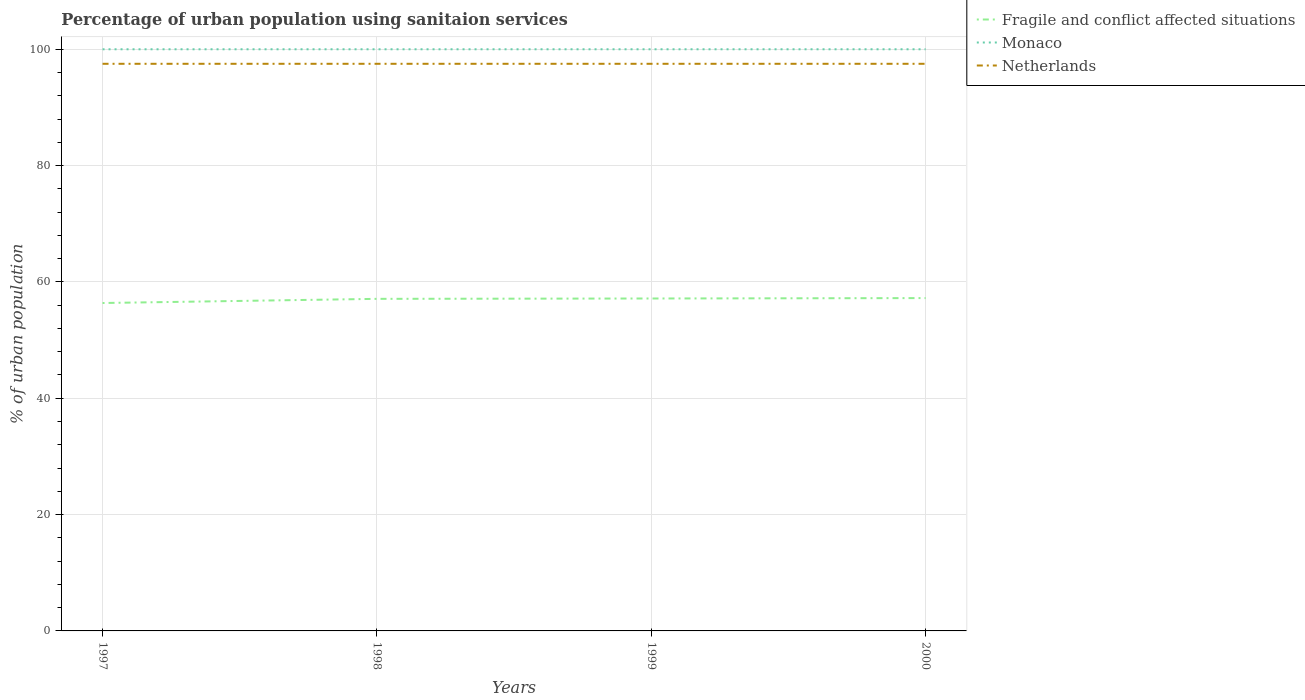Is the number of lines equal to the number of legend labels?
Make the answer very short. Yes. Across all years, what is the maximum percentage of urban population using sanitaion services in Netherlands?
Your response must be concise. 97.5. In which year was the percentage of urban population using sanitaion services in Netherlands maximum?
Provide a succinct answer. 1997. What is the total percentage of urban population using sanitaion services in Monaco in the graph?
Keep it short and to the point. 0. What is the difference between the highest and the second highest percentage of urban population using sanitaion services in Fragile and conflict affected situations?
Offer a terse response. 0.85. Is the percentage of urban population using sanitaion services in Fragile and conflict affected situations strictly greater than the percentage of urban population using sanitaion services in Monaco over the years?
Provide a short and direct response. Yes. How many lines are there?
Your answer should be compact. 3. What is the difference between two consecutive major ticks on the Y-axis?
Keep it short and to the point. 20. Are the values on the major ticks of Y-axis written in scientific E-notation?
Provide a succinct answer. No. Does the graph contain any zero values?
Keep it short and to the point. No. Does the graph contain grids?
Provide a succinct answer. Yes. Where does the legend appear in the graph?
Offer a very short reply. Top right. How are the legend labels stacked?
Provide a succinct answer. Vertical. What is the title of the graph?
Offer a very short reply. Percentage of urban population using sanitaion services. What is the label or title of the X-axis?
Ensure brevity in your answer.  Years. What is the label or title of the Y-axis?
Ensure brevity in your answer.  % of urban population. What is the % of urban population of Fragile and conflict affected situations in 1997?
Make the answer very short. 56.37. What is the % of urban population in Monaco in 1997?
Your response must be concise. 100. What is the % of urban population in Netherlands in 1997?
Keep it short and to the point. 97.5. What is the % of urban population of Fragile and conflict affected situations in 1998?
Provide a succinct answer. 57.09. What is the % of urban population of Monaco in 1998?
Provide a short and direct response. 100. What is the % of urban population in Netherlands in 1998?
Your response must be concise. 97.5. What is the % of urban population in Fragile and conflict affected situations in 1999?
Provide a succinct answer. 57.15. What is the % of urban population of Monaco in 1999?
Your answer should be compact. 100. What is the % of urban population of Netherlands in 1999?
Offer a terse response. 97.5. What is the % of urban population of Fragile and conflict affected situations in 2000?
Provide a succinct answer. 57.22. What is the % of urban population in Netherlands in 2000?
Give a very brief answer. 97.5. Across all years, what is the maximum % of urban population in Fragile and conflict affected situations?
Give a very brief answer. 57.22. Across all years, what is the maximum % of urban population in Monaco?
Your response must be concise. 100. Across all years, what is the maximum % of urban population of Netherlands?
Offer a very short reply. 97.5. Across all years, what is the minimum % of urban population in Fragile and conflict affected situations?
Offer a terse response. 56.37. Across all years, what is the minimum % of urban population in Netherlands?
Your response must be concise. 97.5. What is the total % of urban population of Fragile and conflict affected situations in the graph?
Provide a short and direct response. 227.84. What is the total % of urban population in Netherlands in the graph?
Ensure brevity in your answer.  390. What is the difference between the % of urban population in Fragile and conflict affected situations in 1997 and that in 1998?
Offer a terse response. -0.72. What is the difference between the % of urban population in Netherlands in 1997 and that in 1998?
Keep it short and to the point. 0. What is the difference between the % of urban population of Fragile and conflict affected situations in 1997 and that in 1999?
Give a very brief answer. -0.78. What is the difference between the % of urban population of Fragile and conflict affected situations in 1997 and that in 2000?
Offer a very short reply. -0.85. What is the difference between the % of urban population of Monaco in 1997 and that in 2000?
Your response must be concise. 0. What is the difference between the % of urban population in Netherlands in 1997 and that in 2000?
Your response must be concise. 0. What is the difference between the % of urban population in Fragile and conflict affected situations in 1998 and that in 1999?
Offer a terse response. -0.06. What is the difference between the % of urban population in Monaco in 1998 and that in 1999?
Give a very brief answer. 0. What is the difference between the % of urban population in Netherlands in 1998 and that in 1999?
Offer a very short reply. 0. What is the difference between the % of urban population in Fragile and conflict affected situations in 1998 and that in 2000?
Give a very brief answer. -0.13. What is the difference between the % of urban population in Monaco in 1998 and that in 2000?
Give a very brief answer. 0. What is the difference between the % of urban population in Netherlands in 1998 and that in 2000?
Your answer should be compact. 0. What is the difference between the % of urban population of Fragile and conflict affected situations in 1999 and that in 2000?
Make the answer very short. -0.07. What is the difference between the % of urban population of Monaco in 1999 and that in 2000?
Ensure brevity in your answer.  0. What is the difference between the % of urban population in Fragile and conflict affected situations in 1997 and the % of urban population in Monaco in 1998?
Provide a succinct answer. -43.63. What is the difference between the % of urban population of Fragile and conflict affected situations in 1997 and the % of urban population of Netherlands in 1998?
Give a very brief answer. -41.13. What is the difference between the % of urban population in Fragile and conflict affected situations in 1997 and the % of urban population in Monaco in 1999?
Provide a short and direct response. -43.63. What is the difference between the % of urban population in Fragile and conflict affected situations in 1997 and the % of urban population in Netherlands in 1999?
Ensure brevity in your answer.  -41.13. What is the difference between the % of urban population in Monaco in 1997 and the % of urban population in Netherlands in 1999?
Make the answer very short. 2.5. What is the difference between the % of urban population in Fragile and conflict affected situations in 1997 and the % of urban population in Monaco in 2000?
Provide a succinct answer. -43.63. What is the difference between the % of urban population in Fragile and conflict affected situations in 1997 and the % of urban population in Netherlands in 2000?
Offer a very short reply. -41.13. What is the difference between the % of urban population in Fragile and conflict affected situations in 1998 and the % of urban population in Monaco in 1999?
Make the answer very short. -42.91. What is the difference between the % of urban population in Fragile and conflict affected situations in 1998 and the % of urban population in Netherlands in 1999?
Your answer should be very brief. -40.41. What is the difference between the % of urban population in Monaco in 1998 and the % of urban population in Netherlands in 1999?
Ensure brevity in your answer.  2.5. What is the difference between the % of urban population of Fragile and conflict affected situations in 1998 and the % of urban population of Monaco in 2000?
Your answer should be very brief. -42.91. What is the difference between the % of urban population of Fragile and conflict affected situations in 1998 and the % of urban population of Netherlands in 2000?
Your answer should be very brief. -40.41. What is the difference between the % of urban population in Monaco in 1998 and the % of urban population in Netherlands in 2000?
Your answer should be compact. 2.5. What is the difference between the % of urban population of Fragile and conflict affected situations in 1999 and the % of urban population of Monaco in 2000?
Your answer should be compact. -42.85. What is the difference between the % of urban population in Fragile and conflict affected situations in 1999 and the % of urban population in Netherlands in 2000?
Offer a terse response. -40.35. What is the difference between the % of urban population in Monaco in 1999 and the % of urban population in Netherlands in 2000?
Keep it short and to the point. 2.5. What is the average % of urban population in Fragile and conflict affected situations per year?
Your answer should be very brief. 56.96. What is the average % of urban population in Monaco per year?
Ensure brevity in your answer.  100. What is the average % of urban population of Netherlands per year?
Your answer should be compact. 97.5. In the year 1997, what is the difference between the % of urban population of Fragile and conflict affected situations and % of urban population of Monaco?
Your response must be concise. -43.63. In the year 1997, what is the difference between the % of urban population in Fragile and conflict affected situations and % of urban population in Netherlands?
Your answer should be compact. -41.13. In the year 1998, what is the difference between the % of urban population of Fragile and conflict affected situations and % of urban population of Monaco?
Your answer should be compact. -42.91. In the year 1998, what is the difference between the % of urban population in Fragile and conflict affected situations and % of urban population in Netherlands?
Your answer should be very brief. -40.41. In the year 1999, what is the difference between the % of urban population of Fragile and conflict affected situations and % of urban population of Monaco?
Keep it short and to the point. -42.85. In the year 1999, what is the difference between the % of urban population in Fragile and conflict affected situations and % of urban population in Netherlands?
Ensure brevity in your answer.  -40.35. In the year 2000, what is the difference between the % of urban population of Fragile and conflict affected situations and % of urban population of Monaco?
Make the answer very short. -42.78. In the year 2000, what is the difference between the % of urban population in Fragile and conflict affected situations and % of urban population in Netherlands?
Give a very brief answer. -40.28. What is the ratio of the % of urban population of Fragile and conflict affected situations in 1997 to that in 1998?
Your response must be concise. 0.99. What is the ratio of the % of urban population of Monaco in 1997 to that in 1998?
Offer a terse response. 1. What is the ratio of the % of urban population in Netherlands in 1997 to that in 1998?
Your answer should be compact. 1. What is the ratio of the % of urban population of Fragile and conflict affected situations in 1997 to that in 1999?
Provide a succinct answer. 0.99. What is the ratio of the % of urban population of Netherlands in 1997 to that in 1999?
Your answer should be very brief. 1. What is the ratio of the % of urban population in Fragile and conflict affected situations in 1997 to that in 2000?
Provide a succinct answer. 0.99. What is the ratio of the % of urban population in Monaco in 1997 to that in 2000?
Your answer should be compact. 1. What is the ratio of the % of urban population of Netherlands in 1997 to that in 2000?
Give a very brief answer. 1. What is the ratio of the % of urban population in Fragile and conflict affected situations in 1998 to that in 1999?
Give a very brief answer. 1. What is the ratio of the % of urban population of Netherlands in 1998 to that in 1999?
Offer a terse response. 1. What is the ratio of the % of urban population of Netherlands in 1999 to that in 2000?
Keep it short and to the point. 1. What is the difference between the highest and the second highest % of urban population of Fragile and conflict affected situations?
Provide a short and direct response. 0.07. What is the difference between the highest and the second highest % of urban population in Netherlands?
Your answer should be compact. 0. What is the difference between the highest and the lowest % of urban population of Fragile and conflict affected situations?
Offer a terse response. 0.85. What is the difference between the highest and the lowest % of urban population in Monaco?
Your answer should be very brief. 0. 